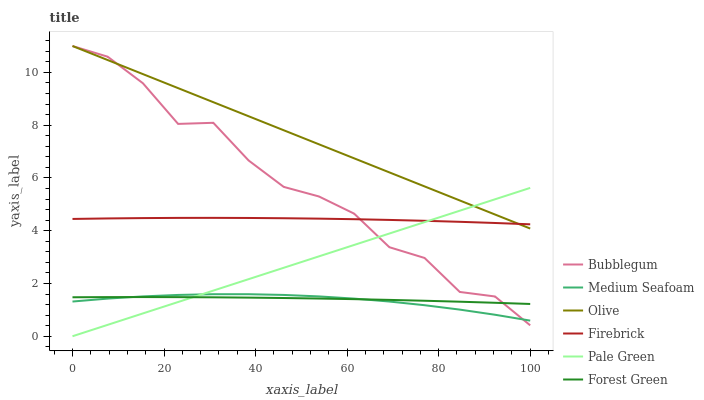Does Medium Seafoam have the minimum area under the curve?
Answer yes or no. Yes. Does Olive have the maximum area under the curve?
Answer yes or no. Yes. Does Bubblegum have the minimum area under the curve?
Answer yes or no. No. Does Bubblegum have the maximum area under the curve?
Answer yes or no. No. Is Pale Green the smoothest?
Answer yes or no. Yes. Is Bubblegum the roughest?
Answer yes or no. Yes. Is Forest Green the smoothest?
Answer yes or no. No. Is Forest Green the roughest?
Answer yes or no. No. Does Pale Green have the lowest value?
Answer yes or no. Yes. Does Bubblegum have the lowest value?
Answer yes or no. No. Does Olive have the highest value?
Answer yes or no. Yes. Does Forest Green have the highest value?
Answer yes or no. No. Is Medium Seafoam less than Olive?
Answer yes or no. Yes. Is Olive greater than Forest Green?
Answer yes or no. Yes. Does Bubblegum intersect Forest Green?
Answer yes or no. Yes. Is Bubblegum less than Forest Green?
Answer yes or no. No. Is Bubblegum greater than Forest Green?
Answer yes or no. No. Does Medium Seafoam intersect Olive?
Answer yes or no. No. 